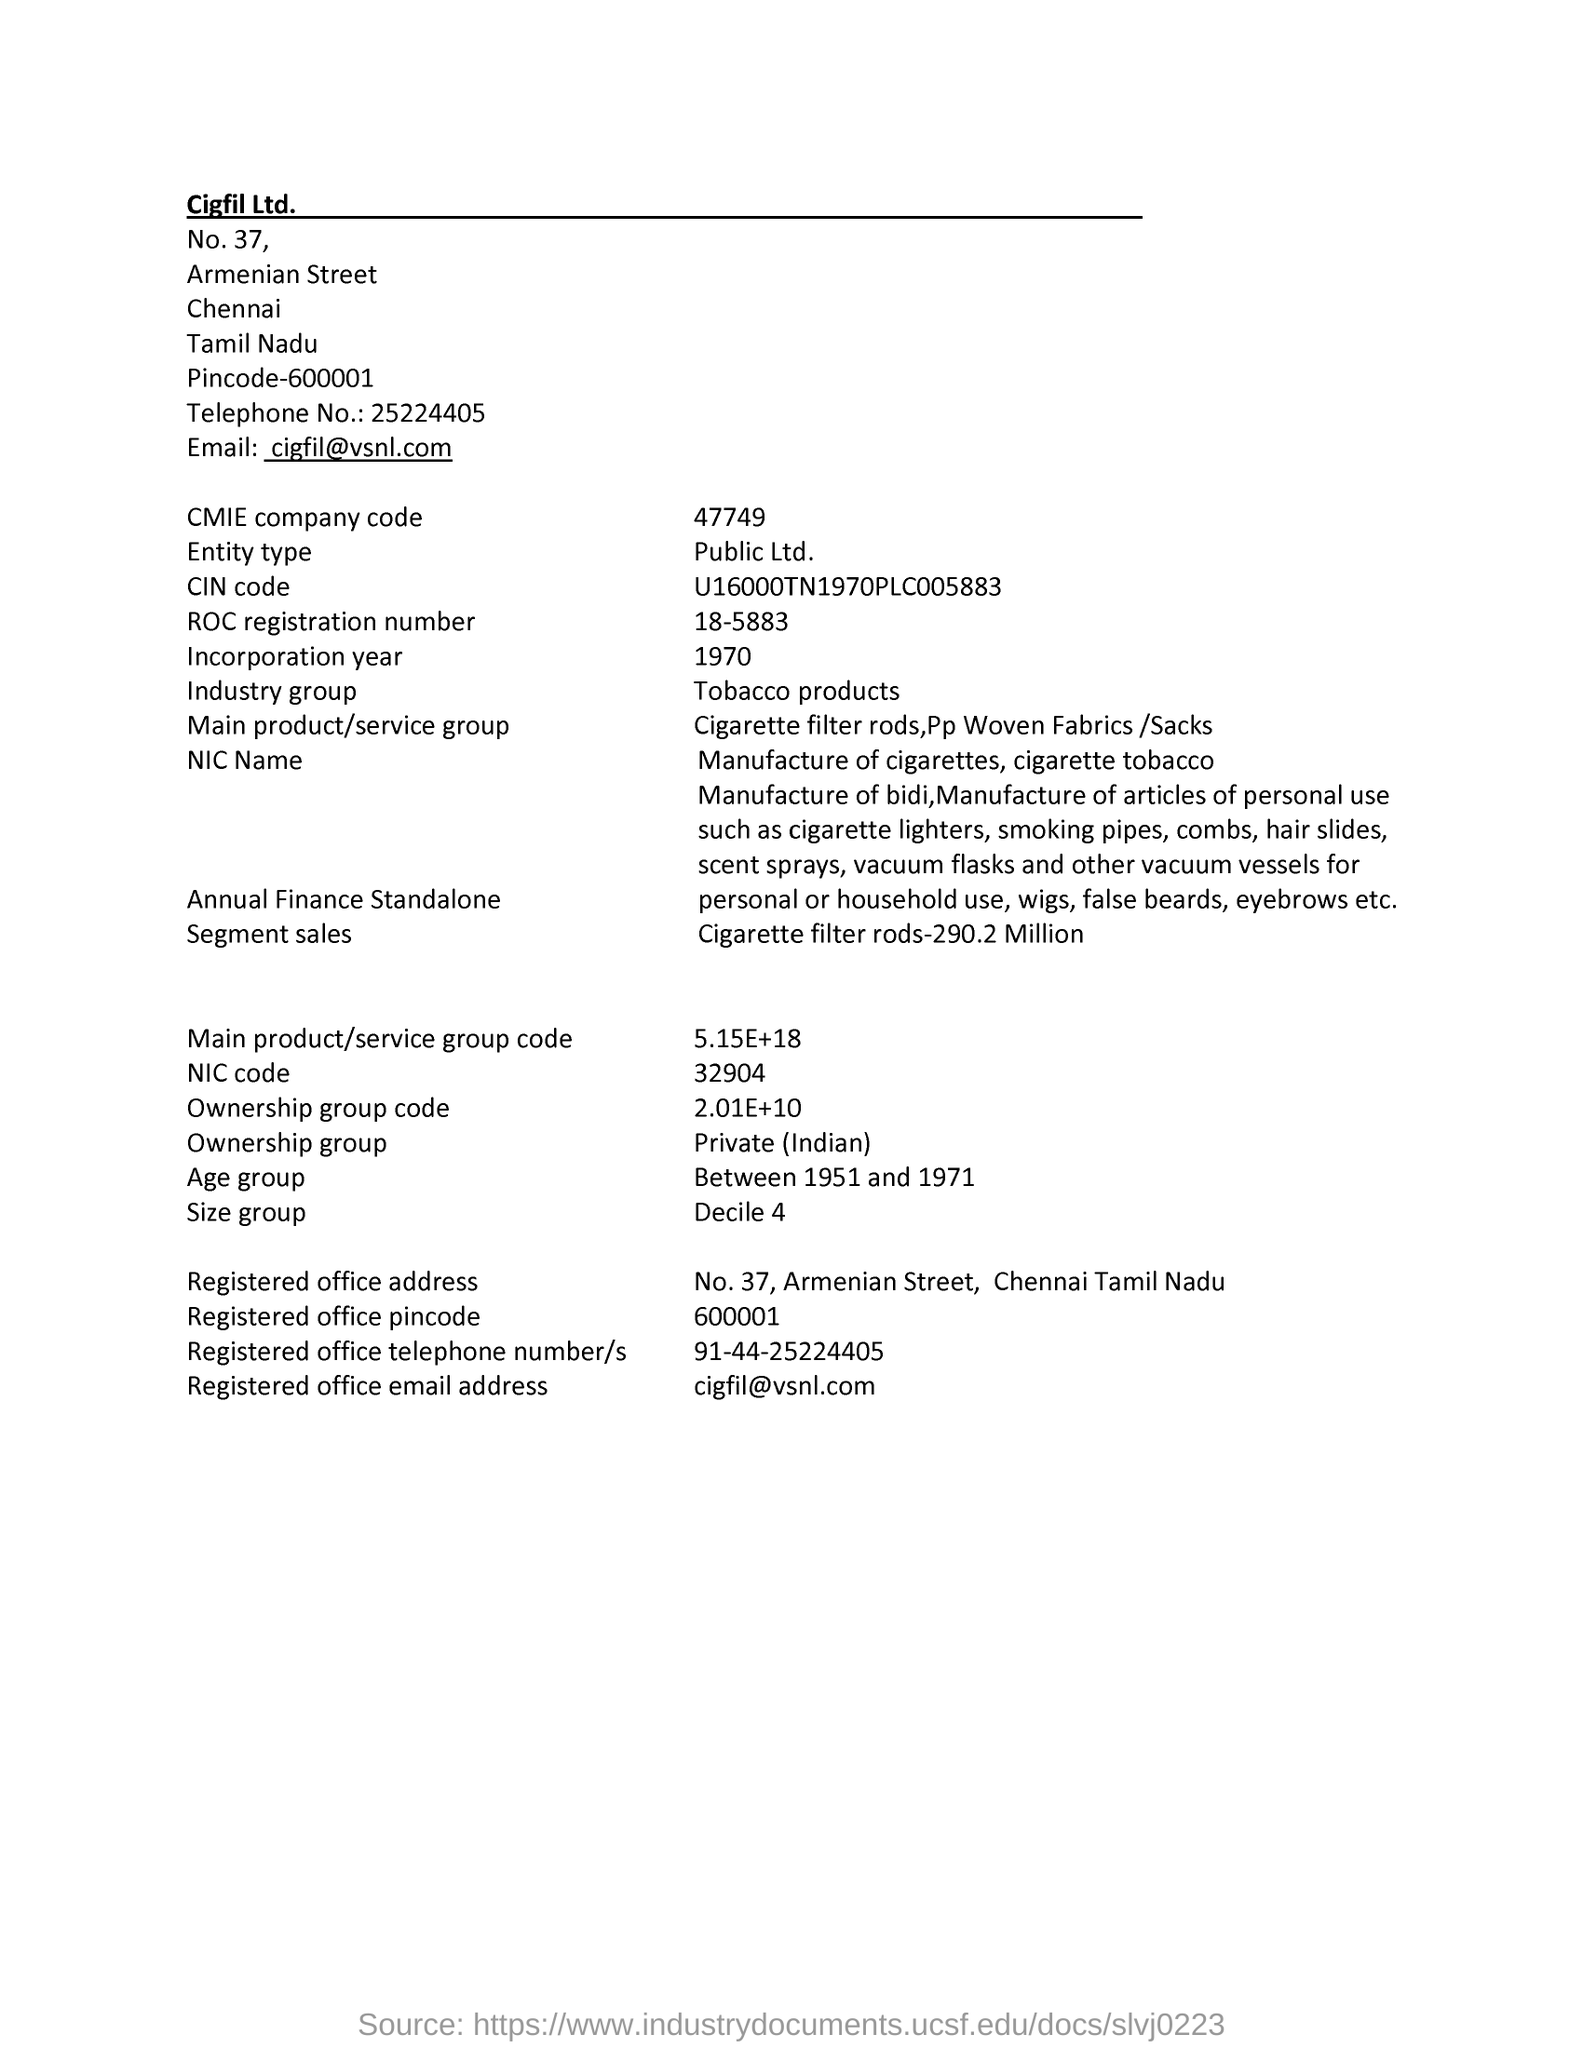Outline some significant characteristics in this image. The entity mentioned in the document is a public limited company. The NIC code given in the document is 32904. The industry group listed in the document is tobacco products. The ROC registration number mentioned in the document is 18-5883. As per the document, the incorporation year is 1970... 